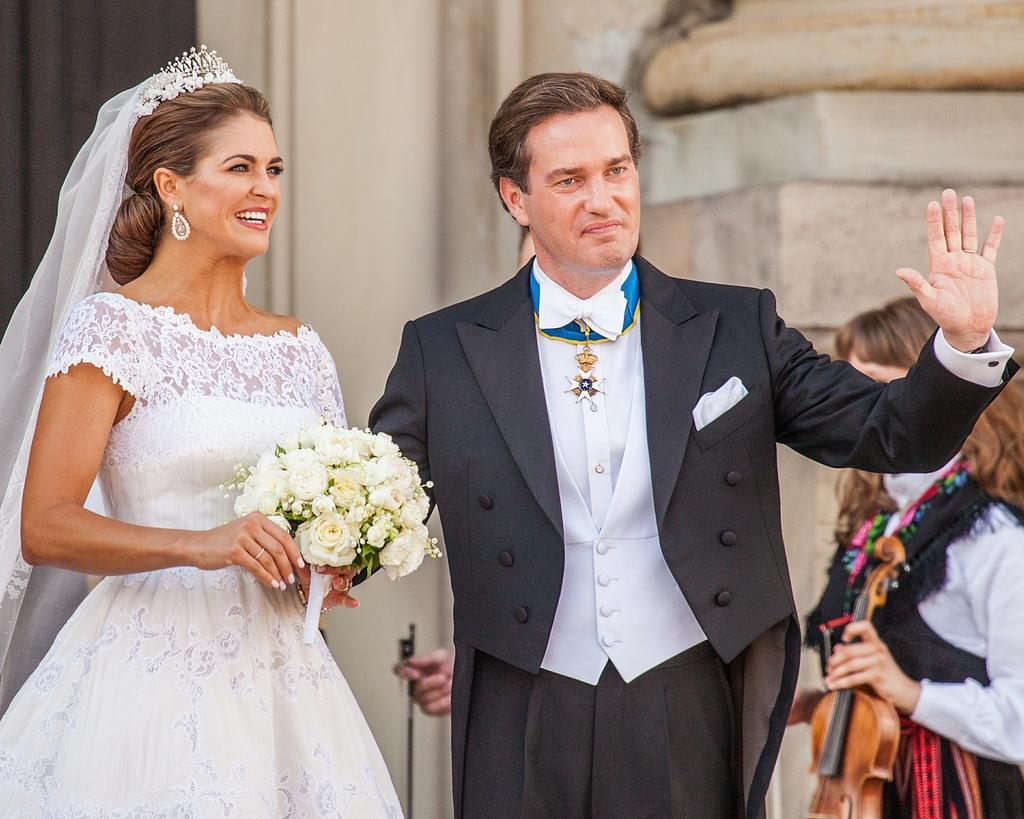How many people are present in the image? There are two people, a man and a woman, present in the image. What are the man and woman doing in the image? They are standing on the ground and holding a bouquet. What can be seen in the background of the image? There are women and a building in the background of the image. What is the texture of the mass in the image? There is no mass present in the image, so it is not possible to determine its texture. 